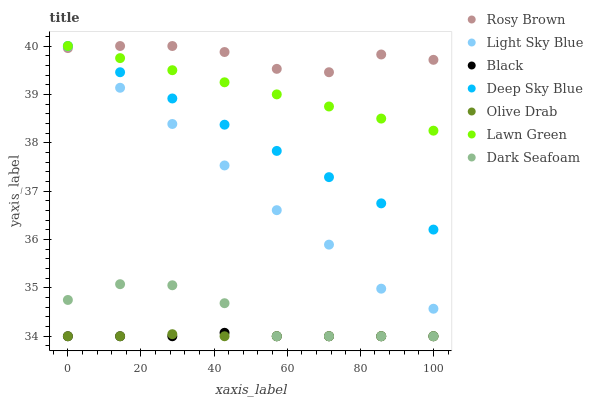Does Olive Drab have the minimum area under the curve?
Answer yes or no. Yes. Does Rosy Brown have the maximum area under the curve?
Answer yes or no. Yes. Does Dark Seafoam have the minimum area under the curve?
Answer yes or no. No. Does Dark Seafoam have the maximum area under the curve?
Answer yes or no. No. Is Lawn Green the smoothest?
Answer yes or no. Yes. Is Dark Seafoam the roughest?
Answer yes or no. Yes. Is Rosy Brown the smoothest?
Answer yes or no. No. Is Rosy Brown the roughest?
Answer yes or no. No. Does Dark Seafoam have the lowest value?
Answer yes or no. Yes. Does Rosy Brown have the lowest value?
Answer yes or no. No. Does Deep Sky Blue have the highest value?
Answer yes or no. Yes. Does Dark Seafoam have the highest value?
Answer yes or no. No. Is Black less than Rosy Brown?
Answer yes or no. Yes. Is Rosy Brown greater than Dark Seafoam?
Answer yes or no. Yes. Does Olive Drab intersect Black?
Answer yes or no. Yes. Is Olive Drab less than Black?
Answer yes or no. No. Is Olive Drab greater than Black?
Answer yes or no. No. Does Black intersect Rosy Brown?
Answer yes or no. No. 